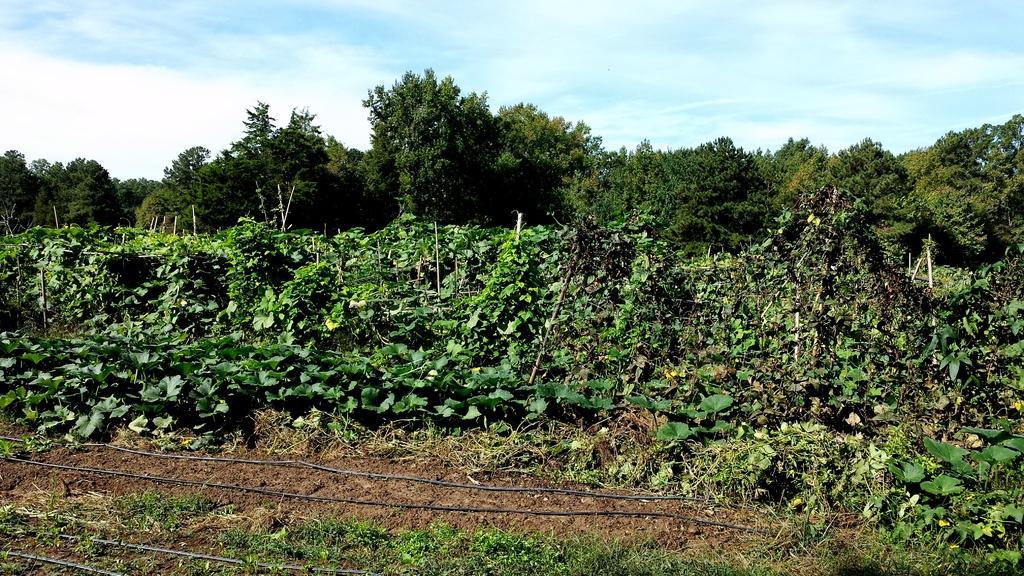How would you summarize this image in a sentence or two? In this image there are some plants in middle of this image and there are some trees in the background and there is a sky at top of this image. There are some wires at bottom of this image. 